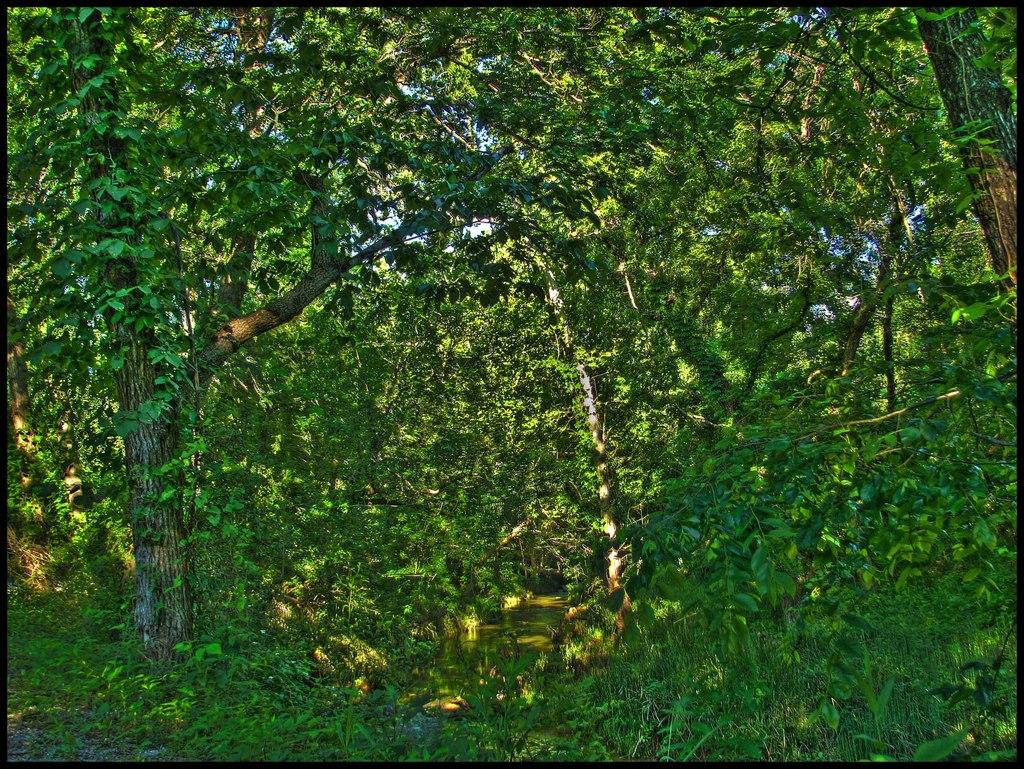What type of vegetation or plants can be seen in the image? There is greenery in the image, which suggests the presence of plants or vegetation. What type of legal advice is the lawyer providing in the image? There is no lawyer or legal advice present in the image; it only features greenery. 